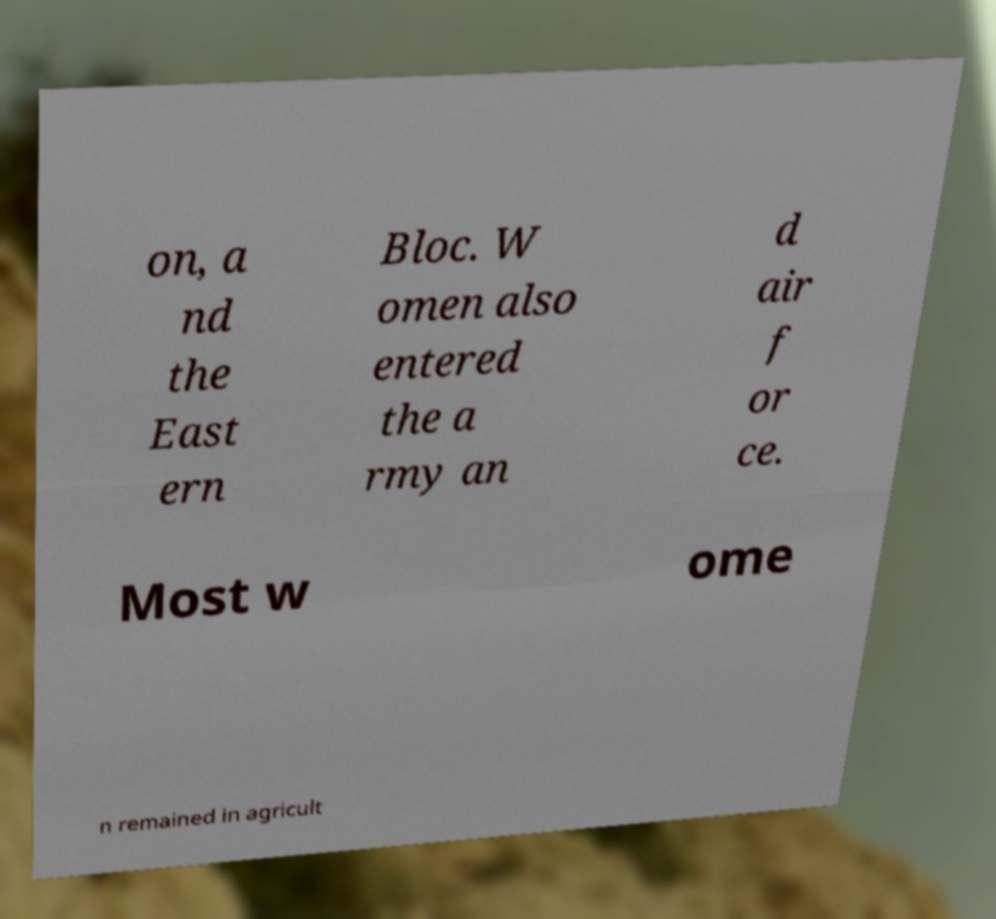Please read and relay the text visible in this image. What does it say? on, a nd the East ern Bloc. W omen also entered the a rmy an d air f or ce. Most w ome n remained in agricult 